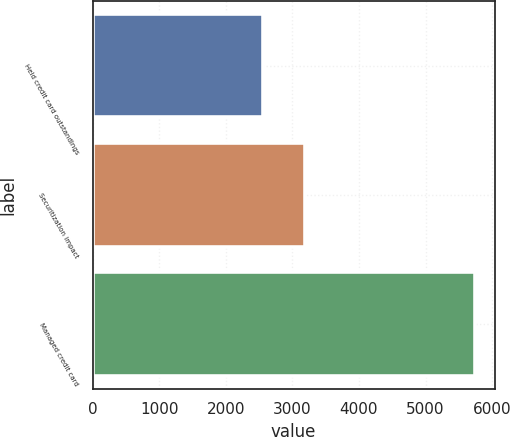<chart> <loc_0><loc_0><loc_500><loc_500><bar_chart><fcel>Held credit card outstandings<fcel>Securitization impact<fcel>Managed credit card<nl><fcel>2565<fcel>3185<fcel>5750<nl></chart> 